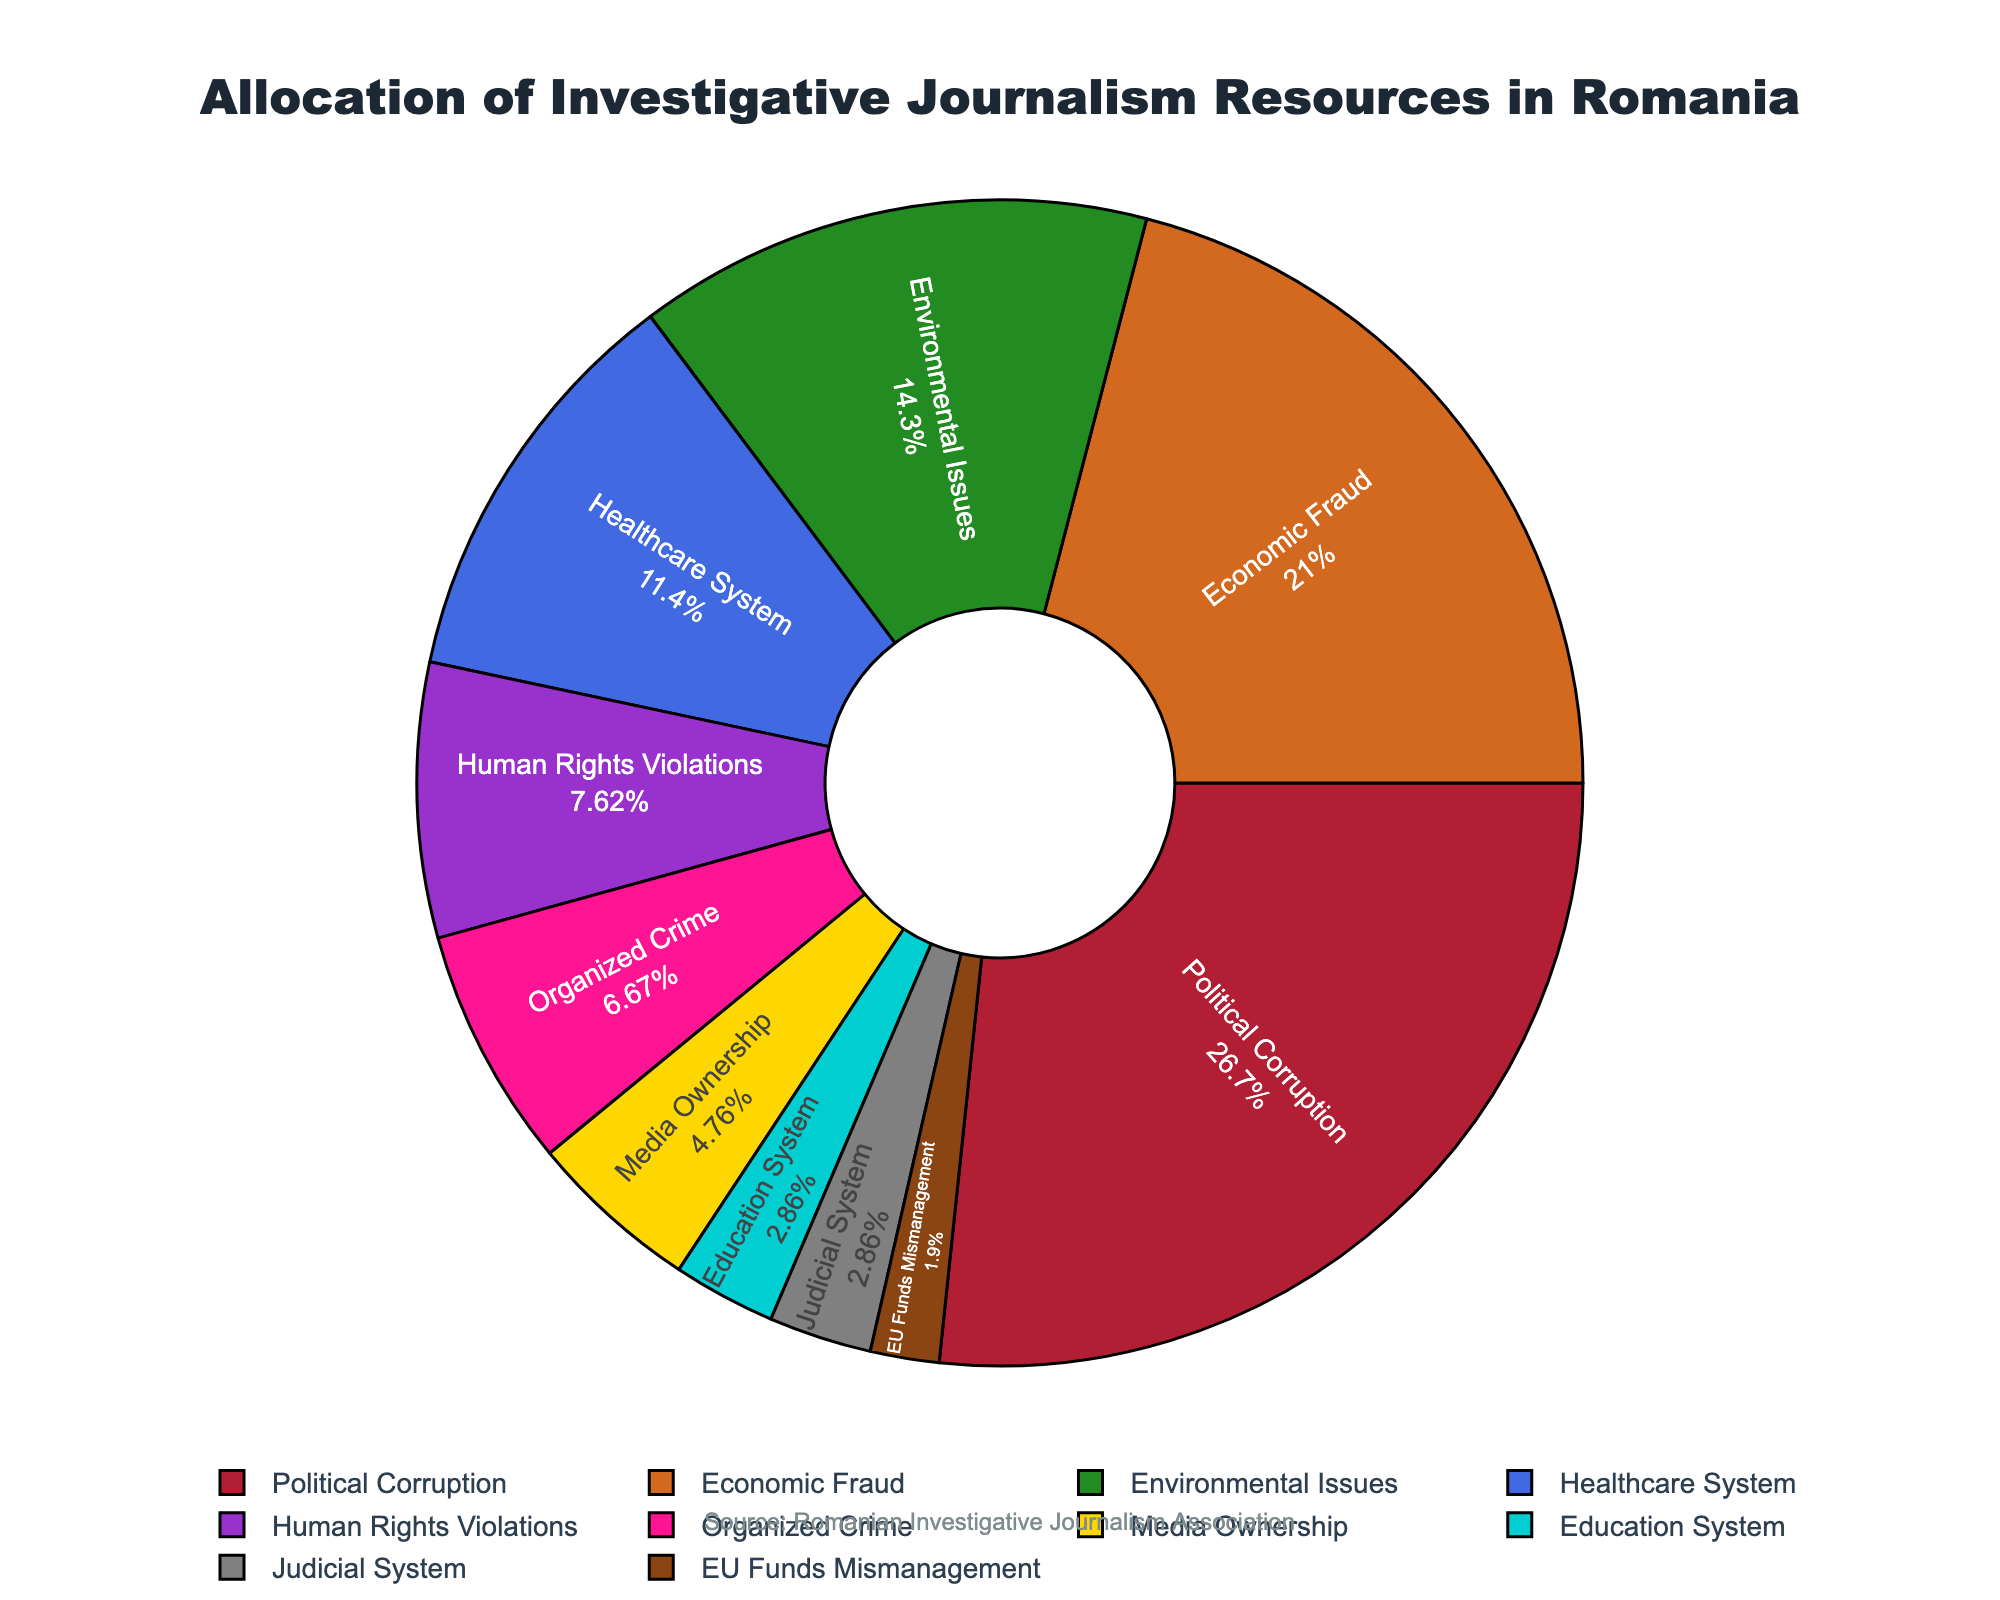What's the largest sector by resource allocation? The largest segment in the pie chart, based on both size and the percentage label, is Political Corruption.
Answer: Political Corruption Which two sectors have the same allocation percentage? Both Education System and Judicial System have a 3% allocation, according to the labels inside the pie chart.
Answer: Education System, Judicial System Which sector is allocated more resources: Healthcare System or Human Rights Violations? By comparing the percentages next to the labels for each sector, Healthcare System has 12% and Human Rights Violations has 8%, so Healthcare System has more.
Answer: Healthcare System What is the total percentage allocation for the top two sectors together? The top two sectors, Political Corruption (28%) and Economic Fraud (22%), together sum up to 28% + 22% = 50%.
Answer: 50% Which sector is allocated the least resources and by how much? By observing the smallest segment, EU Funds Mismanagement is the least allocated with 2%.
Answer: EU Funds Mismanagement, 2% How much more resources are allocated to Environmental Issues compared to Organized Crime? Environmental Issues have 15% and Organized Crime has 7%. The difference is 15% - 7% = 8%.
Answer: 8% What is the combined percentage of sectors that each have an allocation less than 10%? The sectors with less than 10% are Human Rights Violations (8%) + Organized Crime (7%) + Media Ownership (5%) + Education System (3%) + Judicial System (3%) + EU Funds Mismanagement (2%). Summing these gives 8% + 7% + 5% + 3% + 3% + 2% = 28%.
Answer: 28% Which sector representing issues directly affecting public welfare has the highest allocation? Among sectors such as Healthcare System, Environmental Issues, and Education System, the Healthcare System has the highest allocation at 12%.
Answer: Healthcare System What is the difference in resource allocation between Media Ownership and the total allocation for Healthcare System and Human Rights Violations combined? Media Ownership has 5%, and the sum for Healthcare System (12%) and Human Rights Violations (8%) is 12% + 8% = 20%. The difference is 20% - 5% = 15%.
Answer: 15% What is the average allocation percentage for sectors related to governance, i.e., Political Corruption, Economic Fraud, and Judicial System? The sectors are Political Corruption (28%), Economic Fraud (22%), and Judicial System (3%). The average is (28% + 22% + 3%) / 3 = 53% / 3 ≈ 17.67%.
Answer: 17.67% 